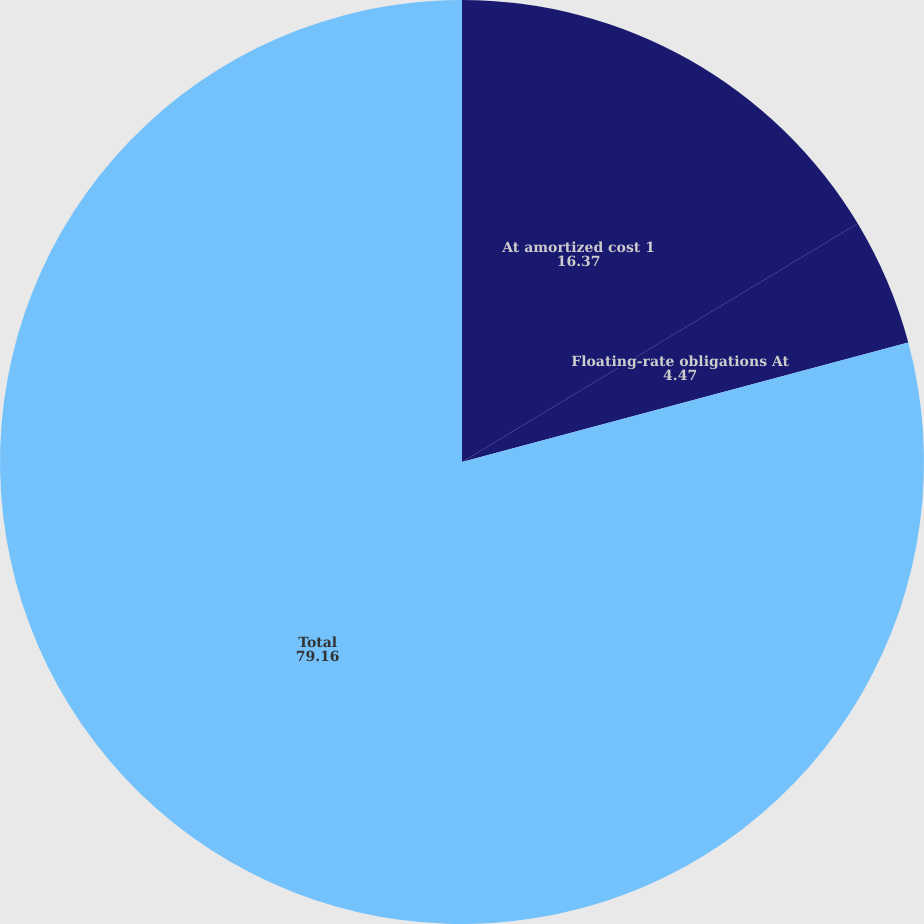Convert chart. <chart><loc_0><loc_0><loc_500><loc_500><pie_chart><fcel>At amortized cost 1<fcel>Floating-rate obligations At<fcel>Total<nl><fcel>16.37%<fcel>4.47%<fcel>79.16%<nl></chart> 